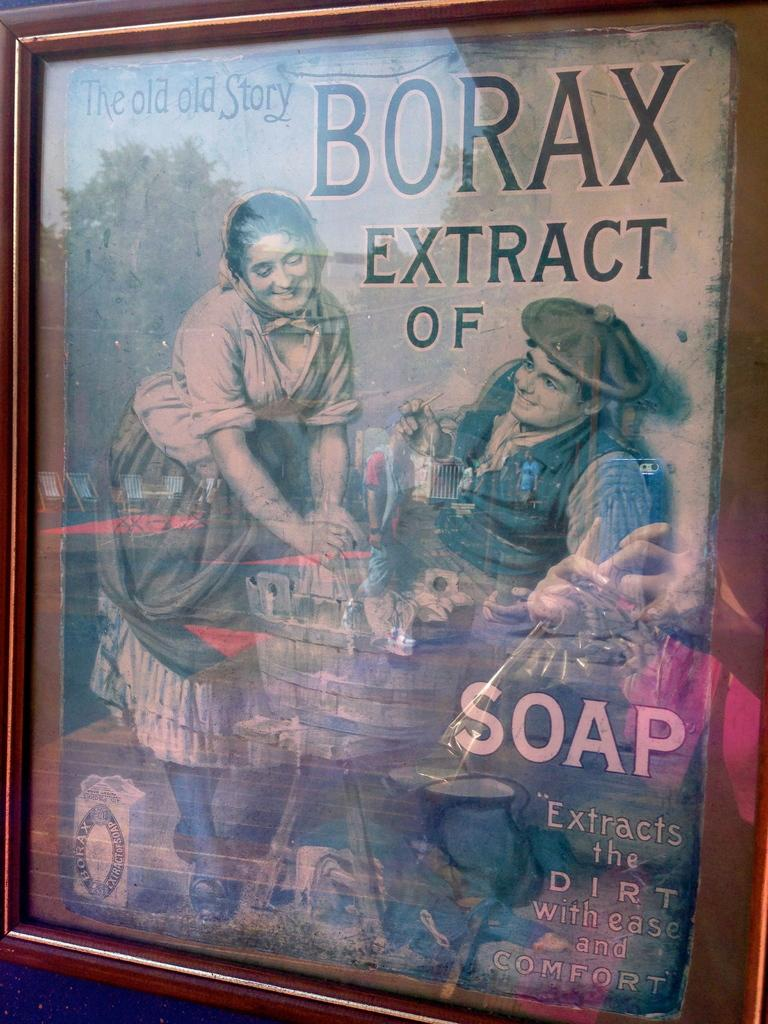<image>
Give a short and clear explanation of the subsequent image. An old magazine cover titled The Old Old Story Borax Extract of Soap 